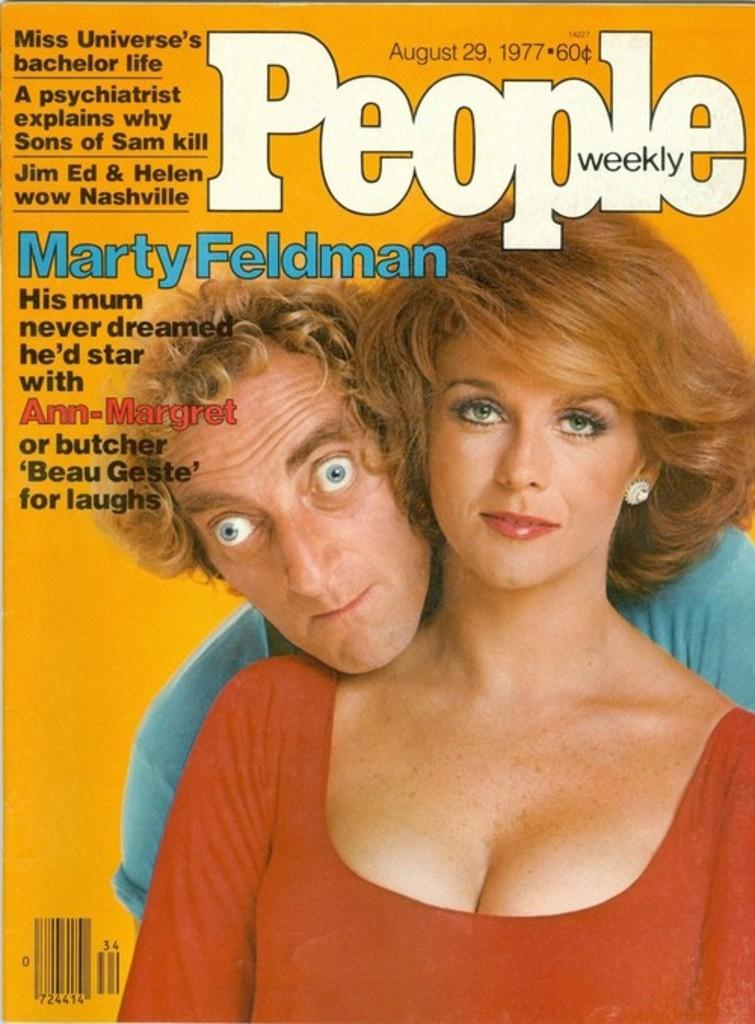What subjects are depicted in the pictures in the image? There are pictures of a man and a woman in the image. What else can be found on the image besides the pictures? There is text on the image. What type of honey is being served at the party in the image? There is no party or honey present in the image; it only contains pictures of a man and a woman with text. 